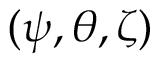<formula> <loc_0><loc_0><loc_500><loc_500>( \psi , \theta , \zeta )</formula> 